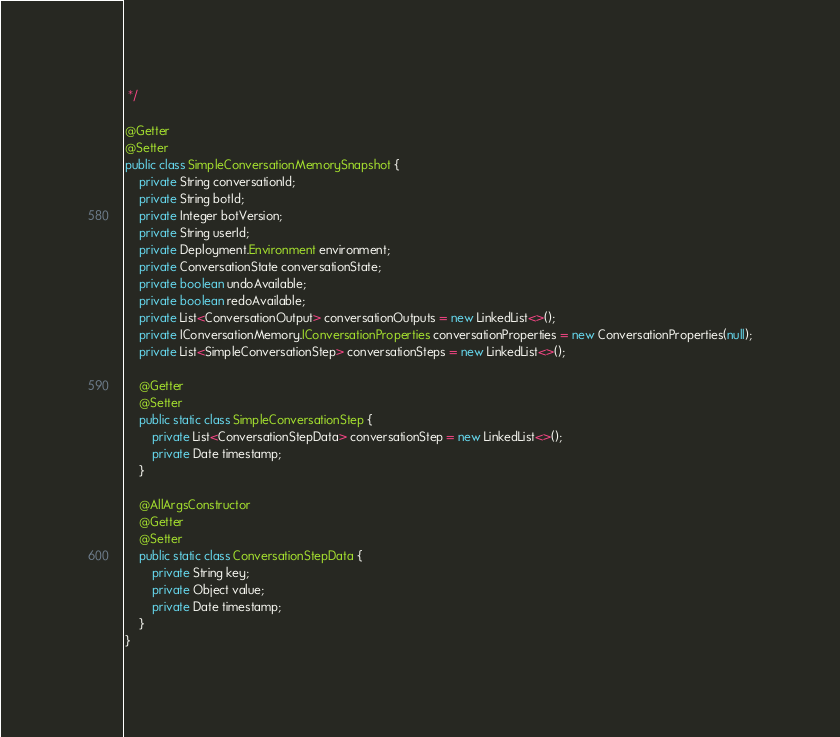<code> <loc_0><loc_0><loc_500><loc_500><_Java_> */

@Getter
@Setter
public class SimpleConversationMemorySnapshot {
    private String conversationId;
    private String botId;
    private Integer botVersion;
    private String userId;
    private Deployment.Environment environment;
    private ConversationState conversationState;
    private boolean undoAvailable;
    private boolean redoAvailable;
    private List<ConversationOutput> conversationOutputs = new LinkedList<>();
    private IConversationMemory.IConversationProperties conversationProperties = new ConversationProperties(null);
    private List<SimpleConversationStep> conversationSteps = new LinkedList<>();

    @Getter
    @Setter
    public static class SimpleConversationStep {
        private List<ConversationStepData> conversationStep = new LinkedList<>();
        private Date timestamp;
    }

    @AllArgsConstructor
    @Getter
    @Setter
    public static class ConversationStepData {
        private String key;
        private Object value;
        private Date timestamp;
    }
}
</code> 